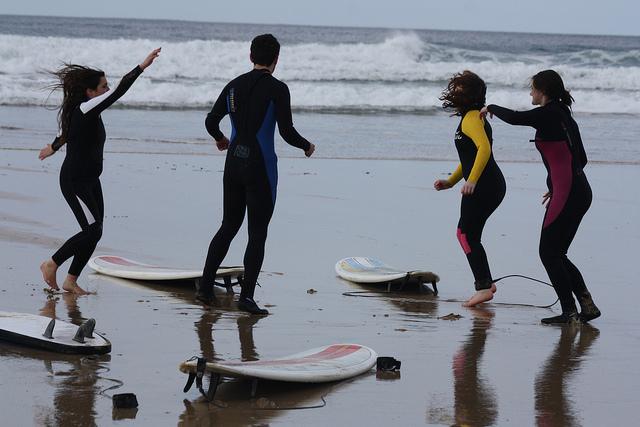Who are on the beach?
Keep it brief. Surfers. Will practicing keep them from falling when they surf for real?
Keep it brief. Yes. Are there more men than women on the beach?
Give a very brief answer. No. Are they all barefoot?
Answer briefly. No. 